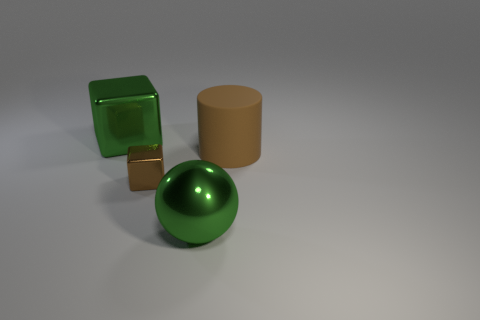What number of big objects are both behind the green ball and left of the brown cylinder?
Offer a very short reply. 1. What material is the cube that is in front of the green metallic cube?
Your answer should be very brief. Metal. What number of big blocks are the same color as the metallic ball?
Your answer should be compact. 1. The green sphere that is the same material as the tiny block is what size?
Provide a short and direct response. Large. How many things are either rubber cylinders or large green metallic cubes?
Make the answer very short. 2. There is a big metallic thing that is behind the large green metallic sphere; what color is it?
Provide a short and direct response. Green. The other object that is the same shape as the small brown thing is what size?
Your answer should be compact. Large. What number of objects are big things in front of the brown rubber object or metallic objects that are to the right of the big green metallic block?
Your response must be concise. 2. There is a metal thing that is both left of the green shiny sphere and in front of the brown matte thing; what is its size?
Make the answer very short. Small. There is a small shiny object; is it the same shape as the green metallic thing behind the brown rubber cylinder?
Ensure brevity in your answer.  Yes. 